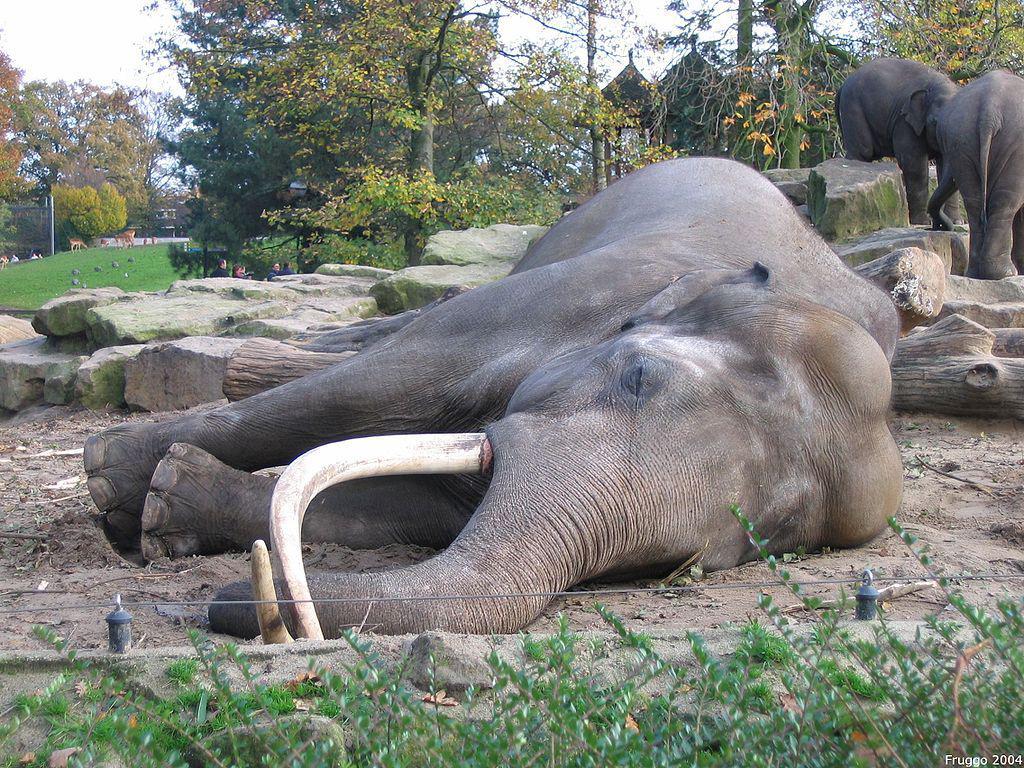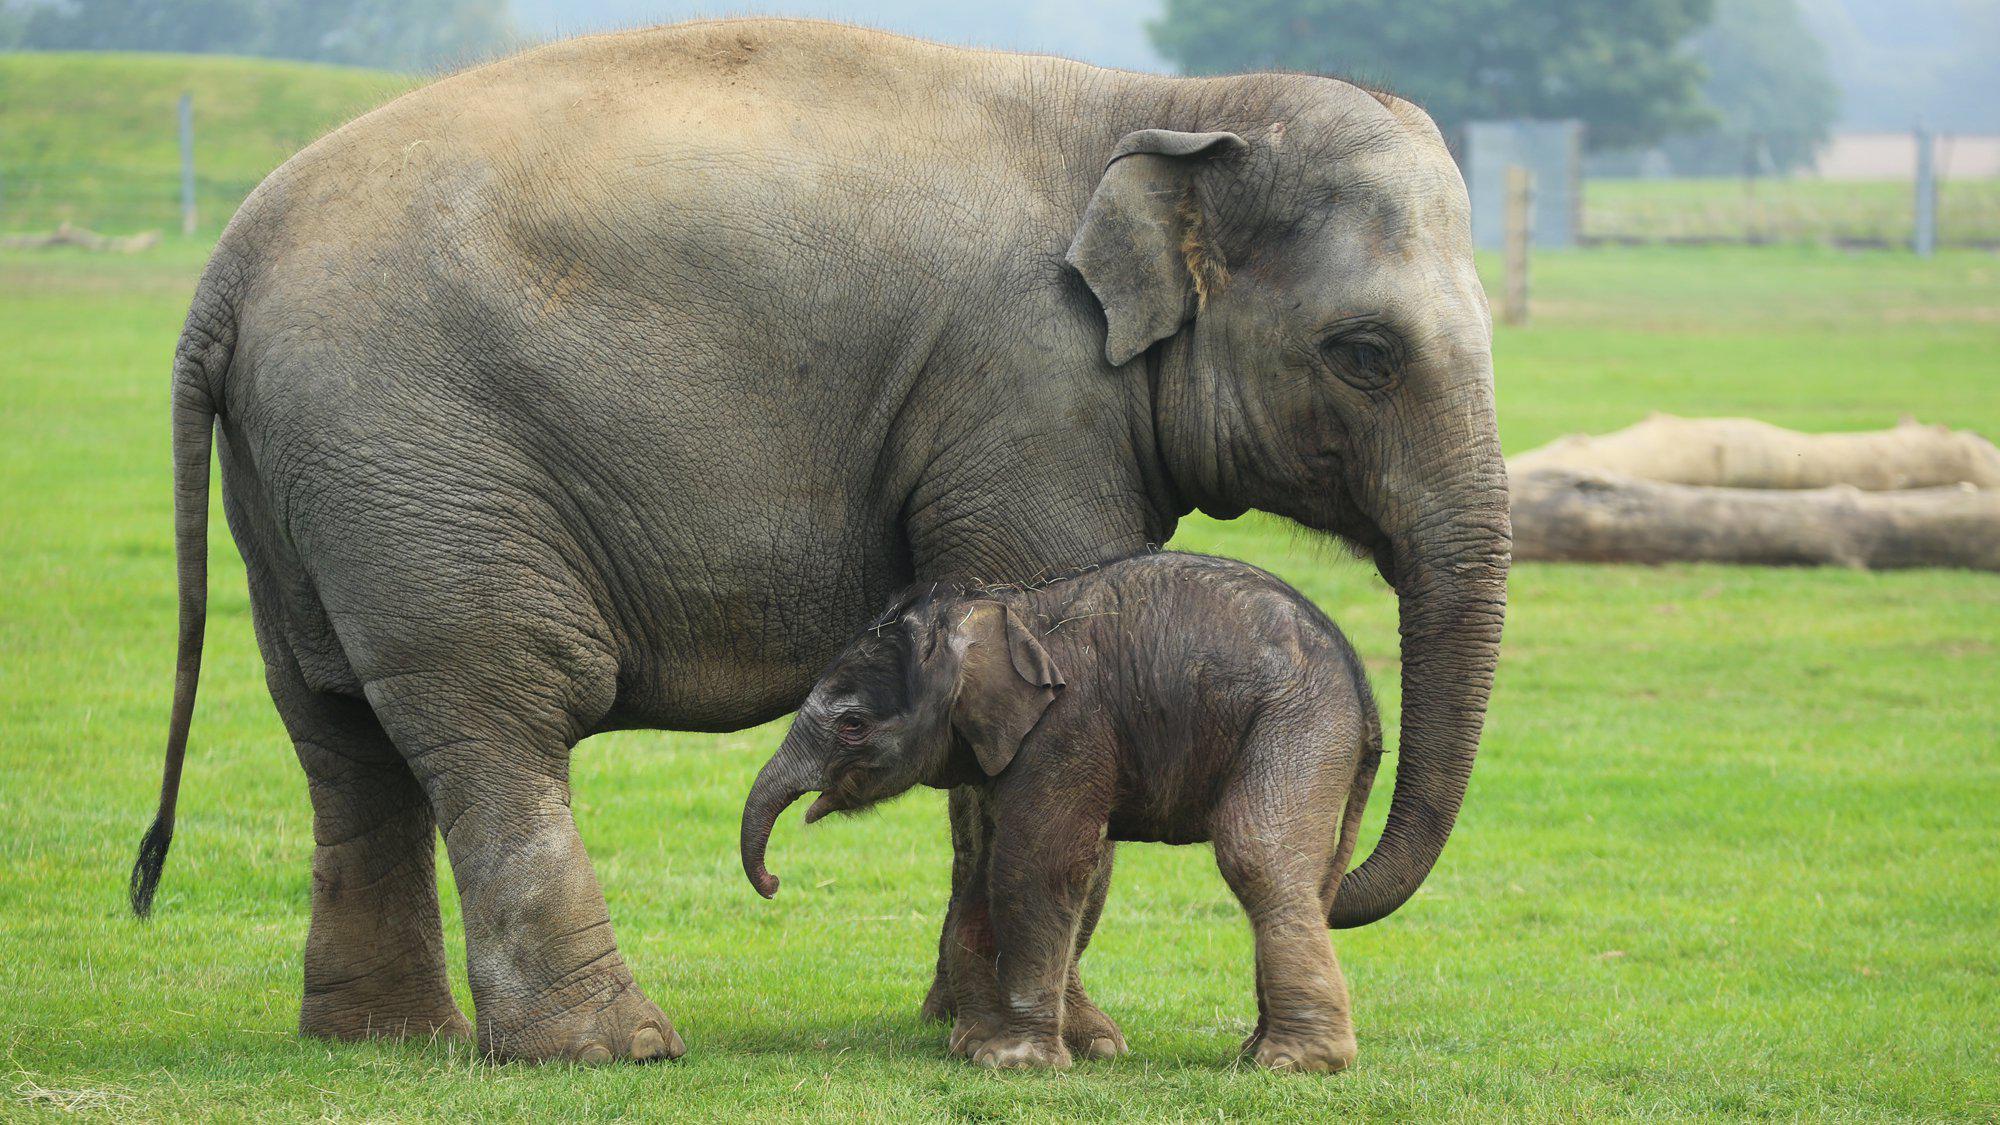The first image is the image on the left, the second image is the image on the right. For the images shown, is this caption "There are more animals on the left than the right." true? Answer yes or no. Yes. 